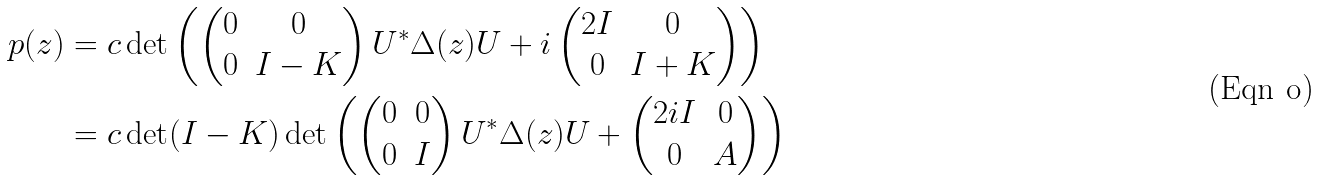Convert formula to latex. <formula><loc_0><loc_0><loc_500><loc_500>p ( z ) & = c \det \left ( \begin{pmatrix} 0 & 0 \\ 0 & I - K \end{pmatrix} U ^ { * } \Delta ( z ) U + i \begin{pmatrix} 2 I & 0 \\ 0 & I + K \end{pmatrix} \right ) \\ & = c \det ( I - K ) \det \left ( \begin{pmatrix} 0 & 0 \\ 0 & I \end{pmatrix} U ^ { * } \Delta ( z ) U + \begin{pmatrix} 2 i I & 0 \\ 0 & A \end{pmatrix} \right )</formula> 